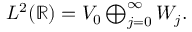Convert formula to latex. <formula><loc_0><loc_0><loc_500><loc_500>\begin{array} { r } { L ^ { 2 } ( \mathbb { R } ) = V _ { 0 } \bigoplus _ { j = 0 } ^ { \infty } W _ { j } . } \end{array}</formula> 